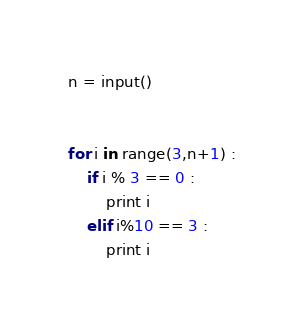Convert code to text. <code><loc_0><loc_0><loc_500><loc_500><_Python_>
n = input()


for i in range(3,n+1) :
    if i % 3 == 0 :
        print i 
    elif i%10 == 3 :
        print i</code> 